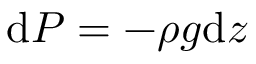Convert formula to latex. <formula><loc_0><loc_0><loc_500><loc_500>d P = - \rho g d z</formula> 